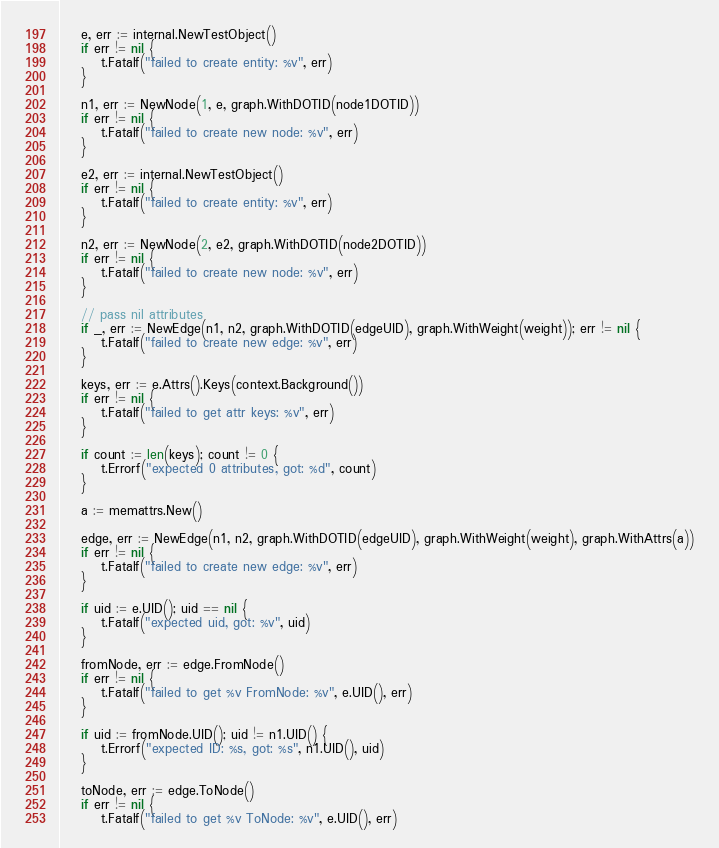<code> <loc_0><loc_0><loc_500><loc_500><_Go_>	e, err := internal.NewTestObject()
	if err != nil {
		t.Fatalf("failed to create entity: %v", err)
	}

	n1, err := NewNode(1, e, graph.WithDOTID(node1DOTID))
	if err != nil {
		t.Fatalf("failed to create new node: %v", err)
	}

	e2, err := internal.NewTestObject()
	if err != nil {
		t.Fatalf("failed to create entity: %v", err)
	}

	n2, err := NewNode(2, e2, graph.WithDOTID(node2DOTID))
	if err != nil {
		t.Fatalf("failed to create new node: %v", err)
	}

	// pass nil attributes
	if _, err := NewEdge(n1, n2, graph.WithDOTID(edgeUID), graph.WithWeight(weight)); err != nil {
		t.Fatalf("failed to create new edge: %v", err)
	}

	keys, err := e.Attrs().Keys(context.Background())
	if err != nil {
		t.Fatalf("failed to get attr keys: %v", err)
	}

	if count := len(keys); count != 0 {
		t.Errorf("expected 0 attributes, got: %d", count)
	}

	a := memattrs.New()

	edge, err := NewEdge(n1, n2, graph.WithDOTID(edgeUID), graph.WithWeight(weight), graph.WithAttrs(a))
	if err != nil {
		t.Fatalf("failed to create new edge: %v", err)
	}

	if uid := e.UID(); uid == nil {
		t.Fatalf("expected uid, got: %v", uid)
	}

	fromNode, err := edge.FromNode()
	if err != nil {
		t.Fatalf("failed to get %v FromNode: %v", e.UID(), err)
	}

	if uid := fromNode.UID(); uid != n1.UID() {
		t.Errorf("expected ID: %s, got: %s", n1.UID(), uid)
	}

	toNode, err := edge.ToNode()
	if err != nil {
		t.Fatalf("failed to get %v ToNode: %v", e.UID(), err)</code> 